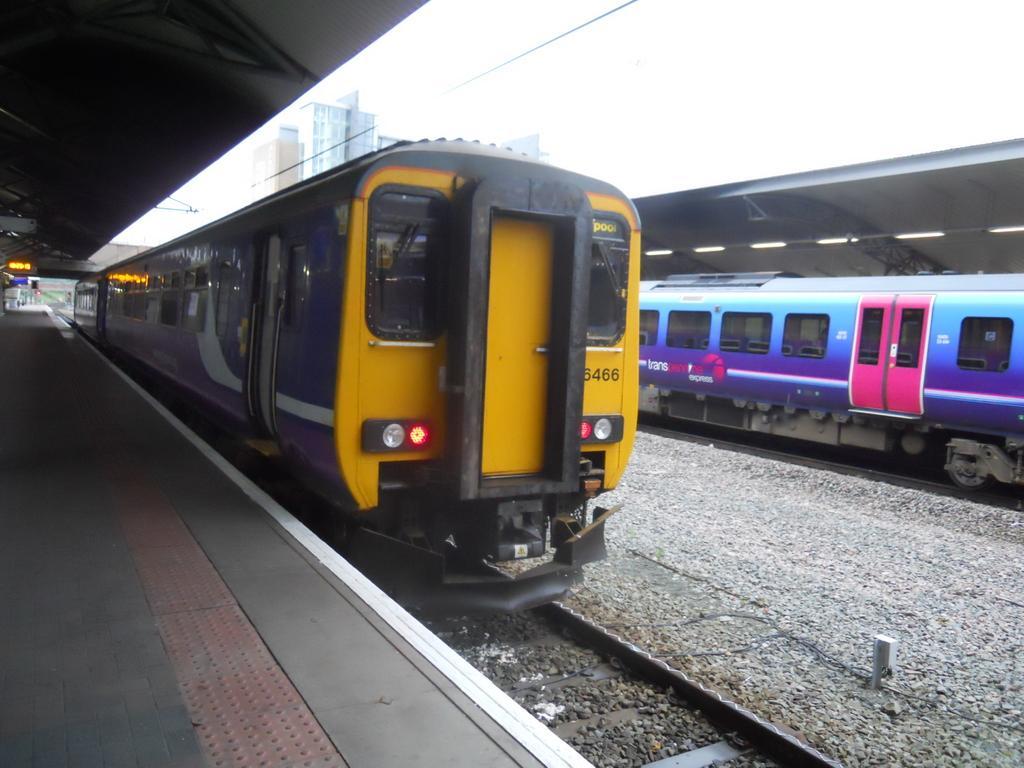Could you give a brief overview of what you see in this image? The picture is clicked inside a railway station. In the foreground we can see stones, railway track, train and platform. On the right there are train, light, shed and stones. In the middle we can see buildings. At the top there is sky. On the left we can see light. 